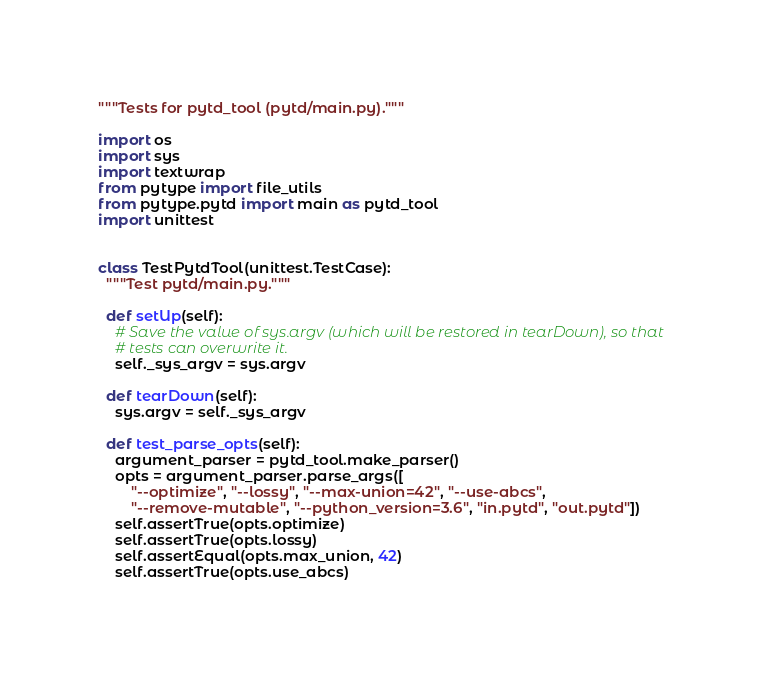Convert code to text. <code><loc_0><loc_0><loc_500><loc_500><_Python_>"""Tests for pytd_tool (pytd/main.py)."""

import os
import sys
import textwrap
from pytype import file_utils
from pytype.pytd import main as pytd_tool
import unittest


class TestPytdTool(unittest.TestCase):
  """Test pytd/main.py."""

  def setUp(self):
    # Save the value of sys.argv (which will be restored in tearDown), so that
    # tests can overwrite it.
    self._sys_argv = sys.argv

  def tearDown(self):
    sys.argv = self._sys_argv

  def test_parse_opts(self):
    argument_parser = pytd_tool.make_parser()
    opts = argument_parser.parse_args([
        "--optimize", "--lossy", "--max-union=42", "--use-abcs",
        "--remove-mutable", "--python_version=3.6", "in.pytd", "out.pytd"])
    self.assertTrue(opts.optimize)
    self.assertTrue(opts.lossy)
    self.assertEqual(opts.max_union, 42)
    self.assertTrue(opts.use_abcs)</code> 